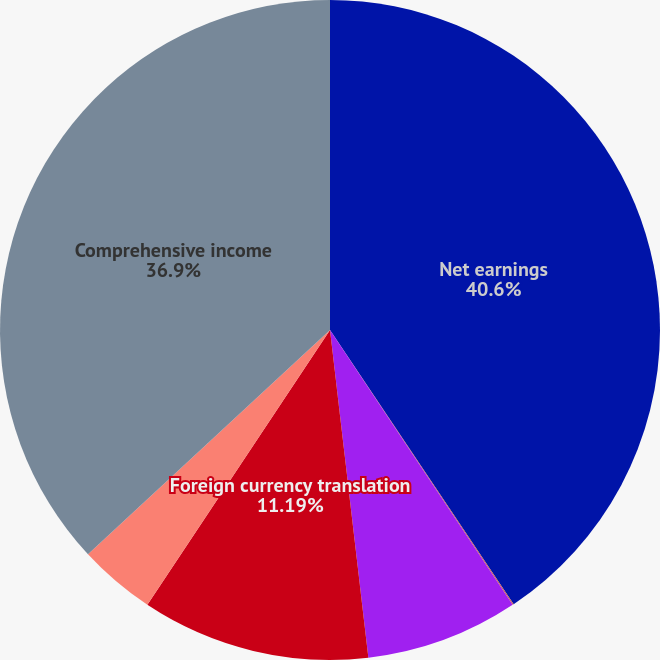Convert chart to OTSL. <chart><loc_0><loc_0><loc_500><loc_500><pie_chart><fcel>Net earnings<fcel>Unrealized gains (losses) on<fcel>Unfunded pension gains<fcel>Foreign currency translation<fcel>Total other comprehensive loss<fcel>Comprehensive income<nl><fcel>40.61%<fcel>0.06%<fcel>7.48%<fcel>11.19%<fcel>3.77%<fcel>36.9%<nl></chart> 